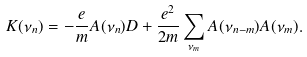<formula> <loc_0><loc_0><loc_500><loc_500>K ( \nu _ { n } ) = - \frac { e } { m } A ( \nu _ { n } ) D + \frac { e ^ { 2 } } { 2 m } \sum _ { \nu _ { m } } A ( \nu _ { n - m } ) A ( \nu _ { m } ) .</formula> 